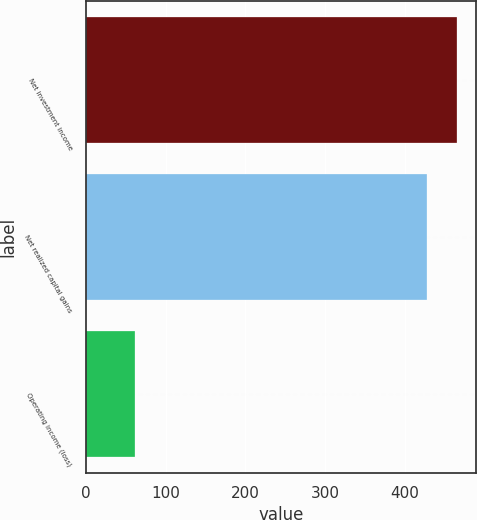<chart> <loc_0><loc_0><loc_500><loc_500><bar_chart><fcel>Net investment income<fcel>Net realized capital gains<fcel>Operating income (loss)<nl><fcel>465.9<fcel>428<fcel>61<nl></chart> 